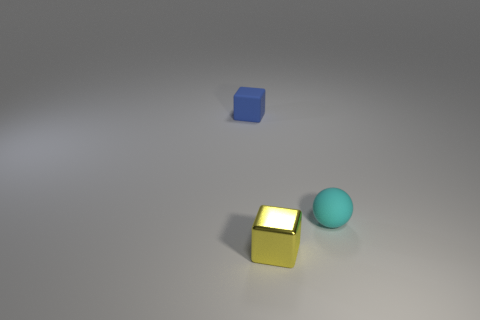Add 3 tiny blue rubber cubes. How many objects exist? 6 Subtract 0 cyan cylinders. How many objects are left? 3 Subtract all cubes. How many objects are left? 1 Subtract all purple blocks. Subtract all red spheres. How many blocks are left? 2 Subtract all big purple cylinders. Subtract all tiny rubber blocks. How many objects are left? 2 Add 3 small blue blocks. How many small blue blocks are left? 4 Add 2 small metal cubes. How many small metal cubes exist? 3 